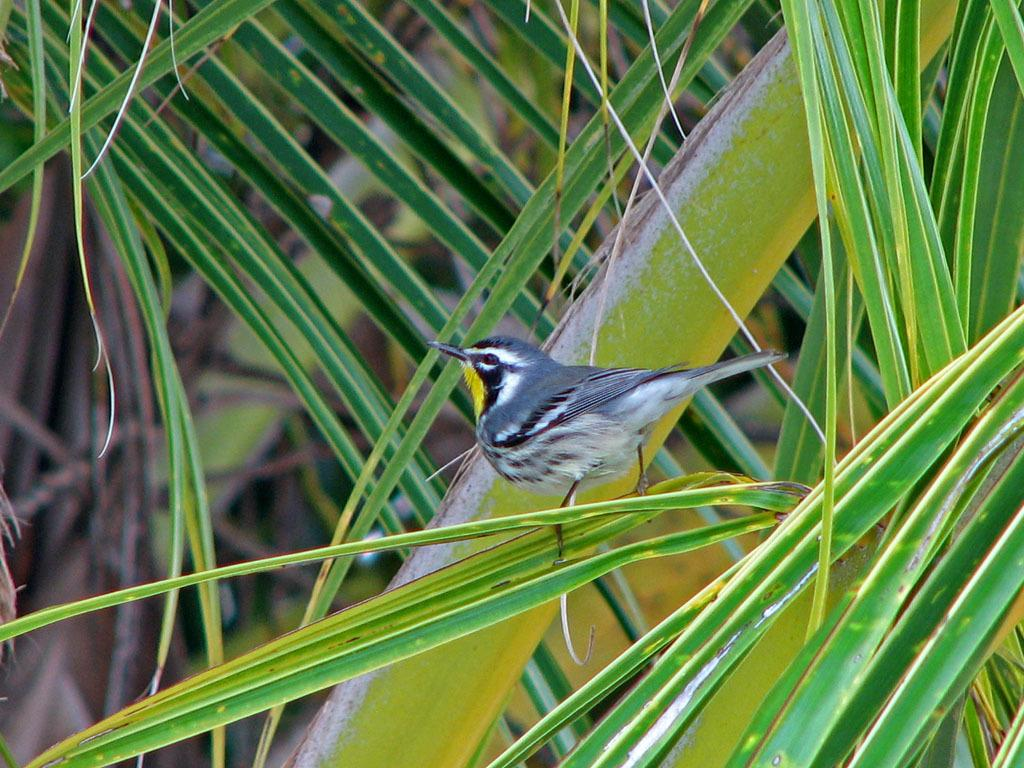What type of vegetation is present in the image? There are green leaves in the image. Is there any animal life visible in the image? Yes, there is a bird on one of the leaves in the image. What is the title of the book that the bird is reading in the image? There is no book or reading activity depicted in the image; it features green leaves and a bird on one of the leaves. What type of twig is the bird holding in its beak in the image? There is no twig visible in the image; the bird is simply perched on one of the leaves. 